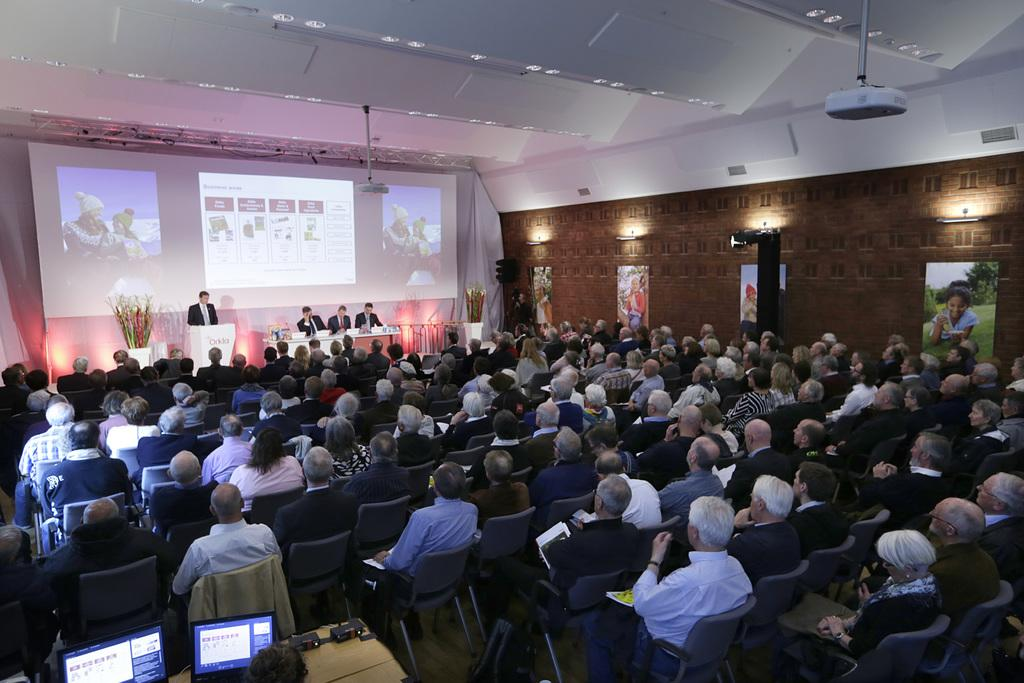What are the people in the image doing? The people in the image are sitting on chairs. Is there anyone standing in the image? Yes, there is a person standing in the image. What can be seen in terms of lighting in the image? Lights are visible in the image. What device is present for displaying visuals? A projector is present in the image. How many chairs are there in the image? There are chairs in the image. What is on the table in the image? There is a screen on the table in the image. What type of toothbrush is being used by the person standing in the image? There is no toothbrush present in the image; the person standing is not using one. How many cars are parked in front of the chairs in the image? There are no cars visible in the image; it only shows people sitting on chairs, a standing person, lights, a projector, chairs, a table, and a screen. 